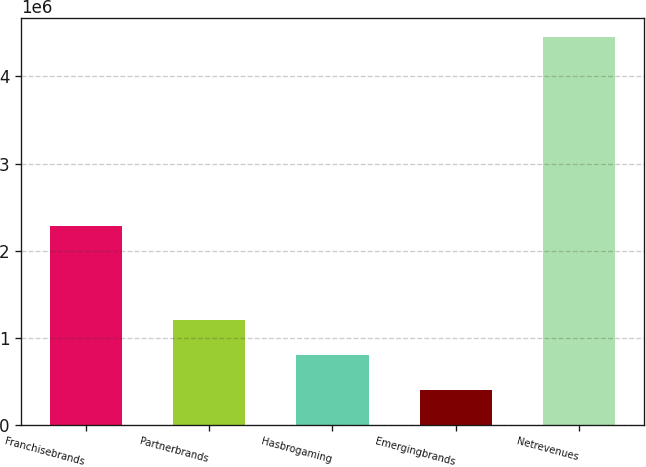Convert chart. <chart><loc_0><loc_0><loc_500><loc_500><bar_chart><fcel>Franchisebrands<fcel>Partnerbrands<fcel>Hasbrogaming<fcel>Emergingbrands<fcel>Netrevenues<nl><fcel>2.28541e+06<fcel>1.20828e+06<fcel>803375<fcel>398471<fcel>4.44751e+06<nl></chart> 